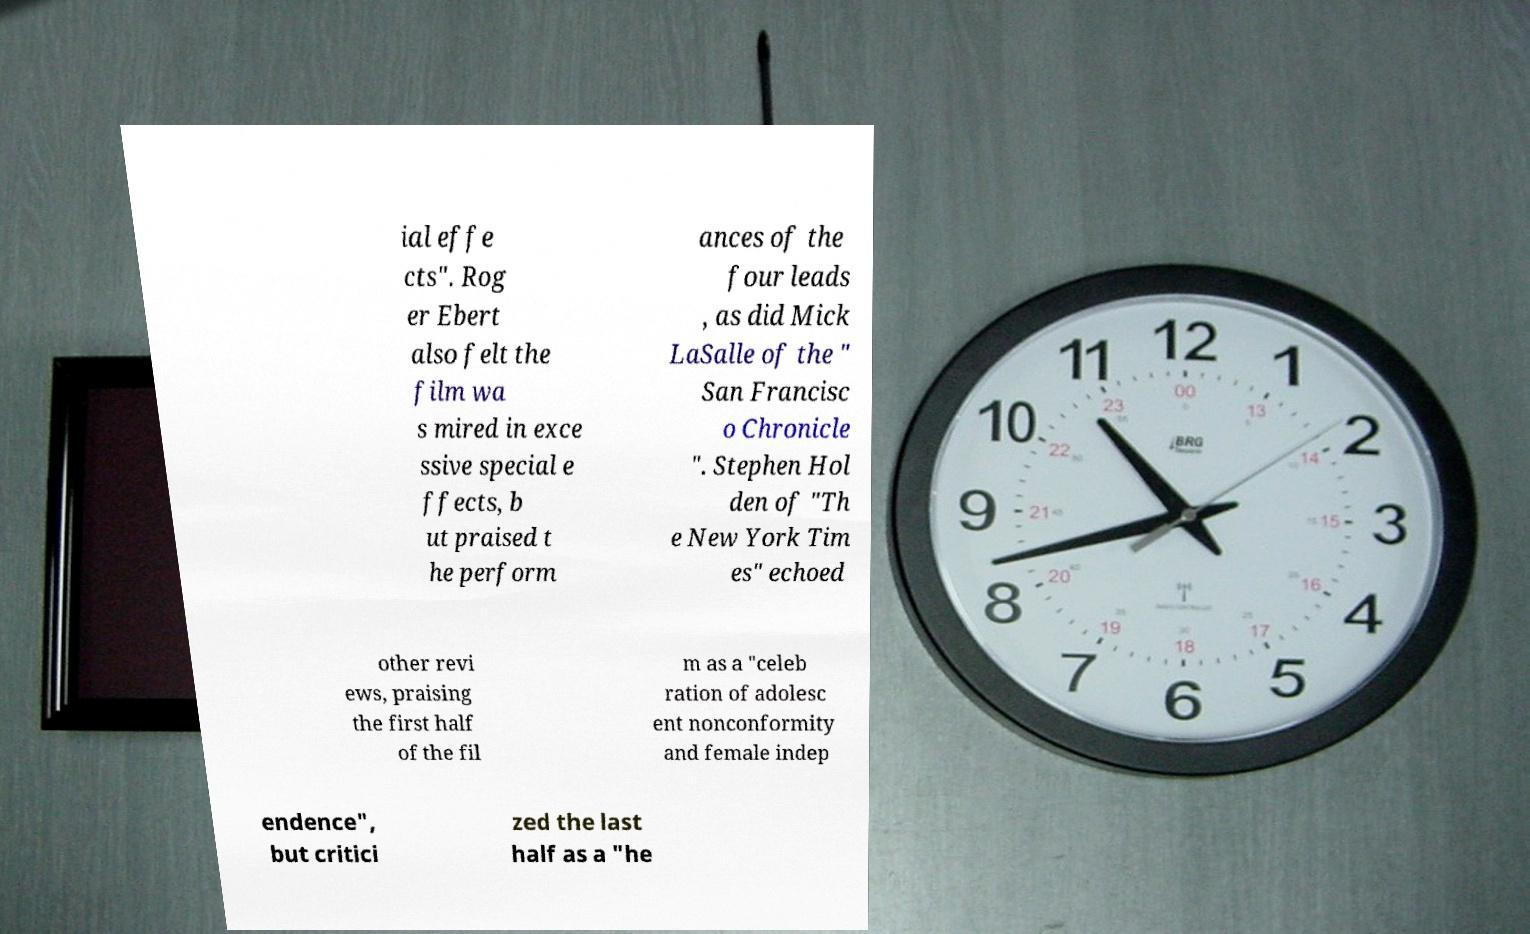For documentation purposes, I need the text within this image transcribed. Could you provide that? ial effe cts". Rog er Ebert also felt the film wa s mired in exce ssive special e ffects, b ut praised t he perform ances of the four leads , as did Mick LaSalle of the " San Francisc o Chronicle ". Stephen Hol den of "Th e New York Tim es" echoed other revi ews, praising the first half of the fil m as a "celeb ration of adolesc ent nonconformity and female indep endence", but critici zed the last half as a "he 